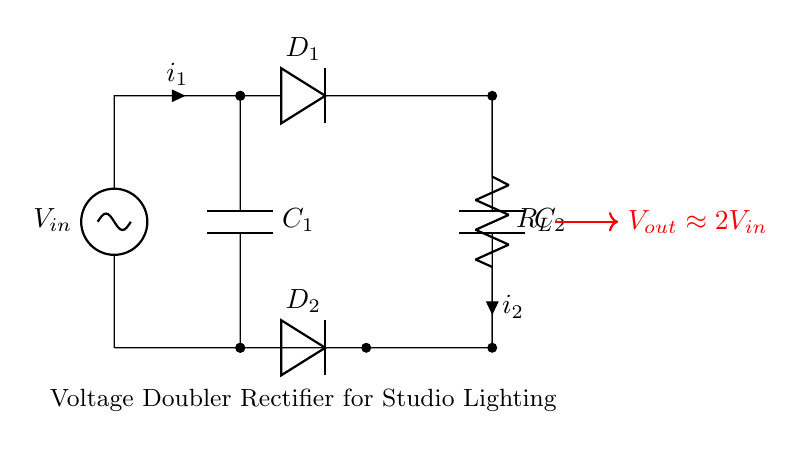What is the input voltage in this circuit? The input voltage is indicated as V in the diagram, referenced from the voltage source at the top of the circuit.
Answer: V in What are the two types of capacitors used in this circuit? The circuit diagram shows two capacitors, C1 and C2, which are clearly labeled with these designations.
Answer: C1 and C2 How many diodes are present in the circuit? There are two diodes, D1 and D2, which are marked in the circuit diagram, one above and one below the center line of the layout.
Answer: 2 What does the output voltage approximately equal? The output voltage is indicated as approximately 2 times the input voltage, shown in the red text with an arrow pointing to it in the diagram.
Answer: 2V in Why is this circuit referred to as a voltage doubler rectifier? The circuit is called a voltage doubler rectifier because it uses a specific arrangement of diodes and capacitors to double the input voltage at the output, as indicated by the output voltage description.
Answer: Voltage doubler What is the role of the resistive load in this circuit? The resistive load, R_L, at the output serves to draw current from the output voltage, allowing it to power the connected lighting system or other devices using the increased voltage.
Answer: Draw current What would happen if one of the diodes failed? If one diode failed, the circuit would not function correctly; specifically, the voltage doubling effect would be lost, leading to reduced output voltage and potential instability.
Answer: Output voltage drops 